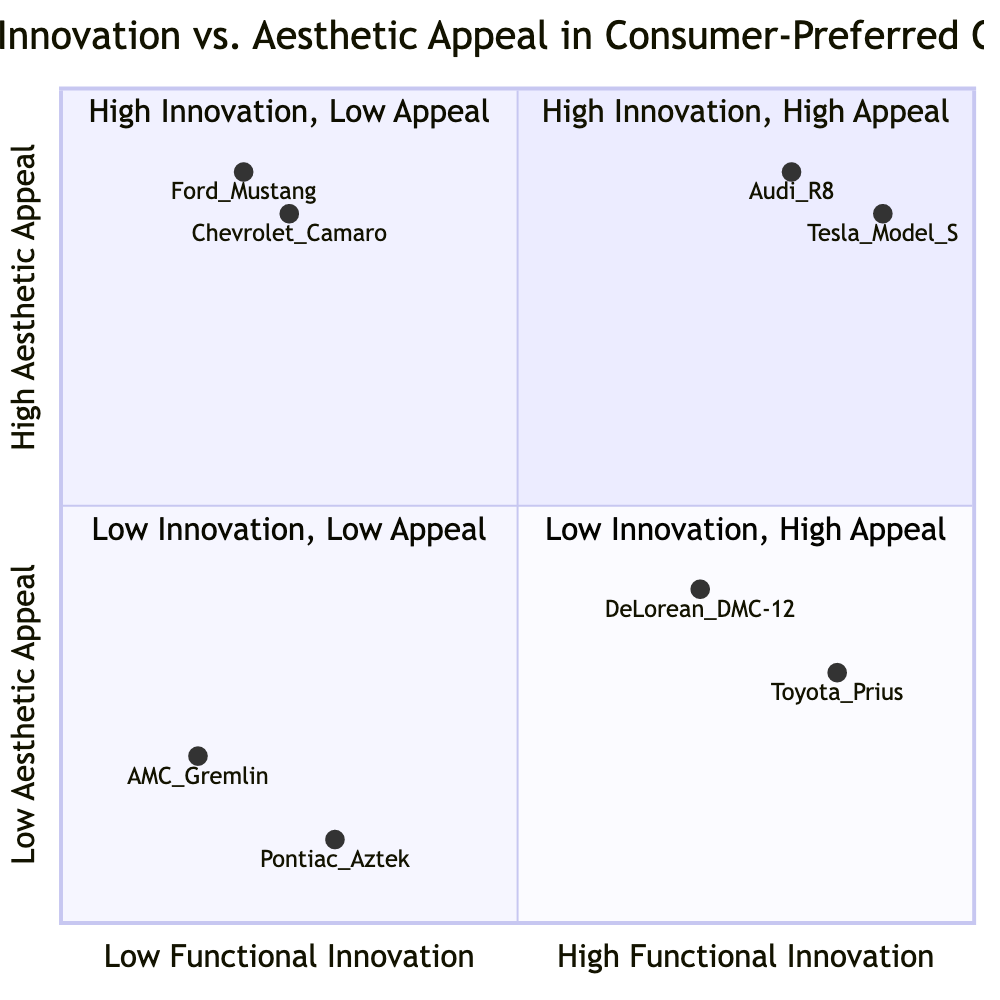What models are in the High Functional Innovation, High Aesthetic Appeal quadrant? This quadrant includes the Tesla Model S and the Audi R8, which are noted for their combination of advanced technology and appealing designs.
Answer: Tesla Model S, Audi R8 Which model has the lowest aesthetic appeal according to the diagram? The Pontiac Aztek, located in the Low Functional Innovation, Low Aesthetic Appeal quadrant, is described as having unattractive design and lacks innovation.
Answer: Pontiac Aztek How many models are categorized under Low Functional Innovation, High Aesthetic Appeal? In this quadrant, there are two models listed: the Ford Mustang and the Chevrolet Camaro, both known for their strong visual designs despite limited technological advancements.
Answer: 2 Which car model was introduced in 1997? The Toyota Prius, found in the High Functional Innovation, Low Aesthetic Appeal quadrant, was introduced in 1997 and is recognized for its hybrid technology.
Answer: Toyota Prius Considering the diagram, which model has the highest functional innovation? The Tesla Model S is positioned at the highest point on the functional innovation scale in the High Functional Innovation, High Aesthetic Appeal quadrant, reflecting its advanced electric vehicle technology.
Answer: Tesla Model S 